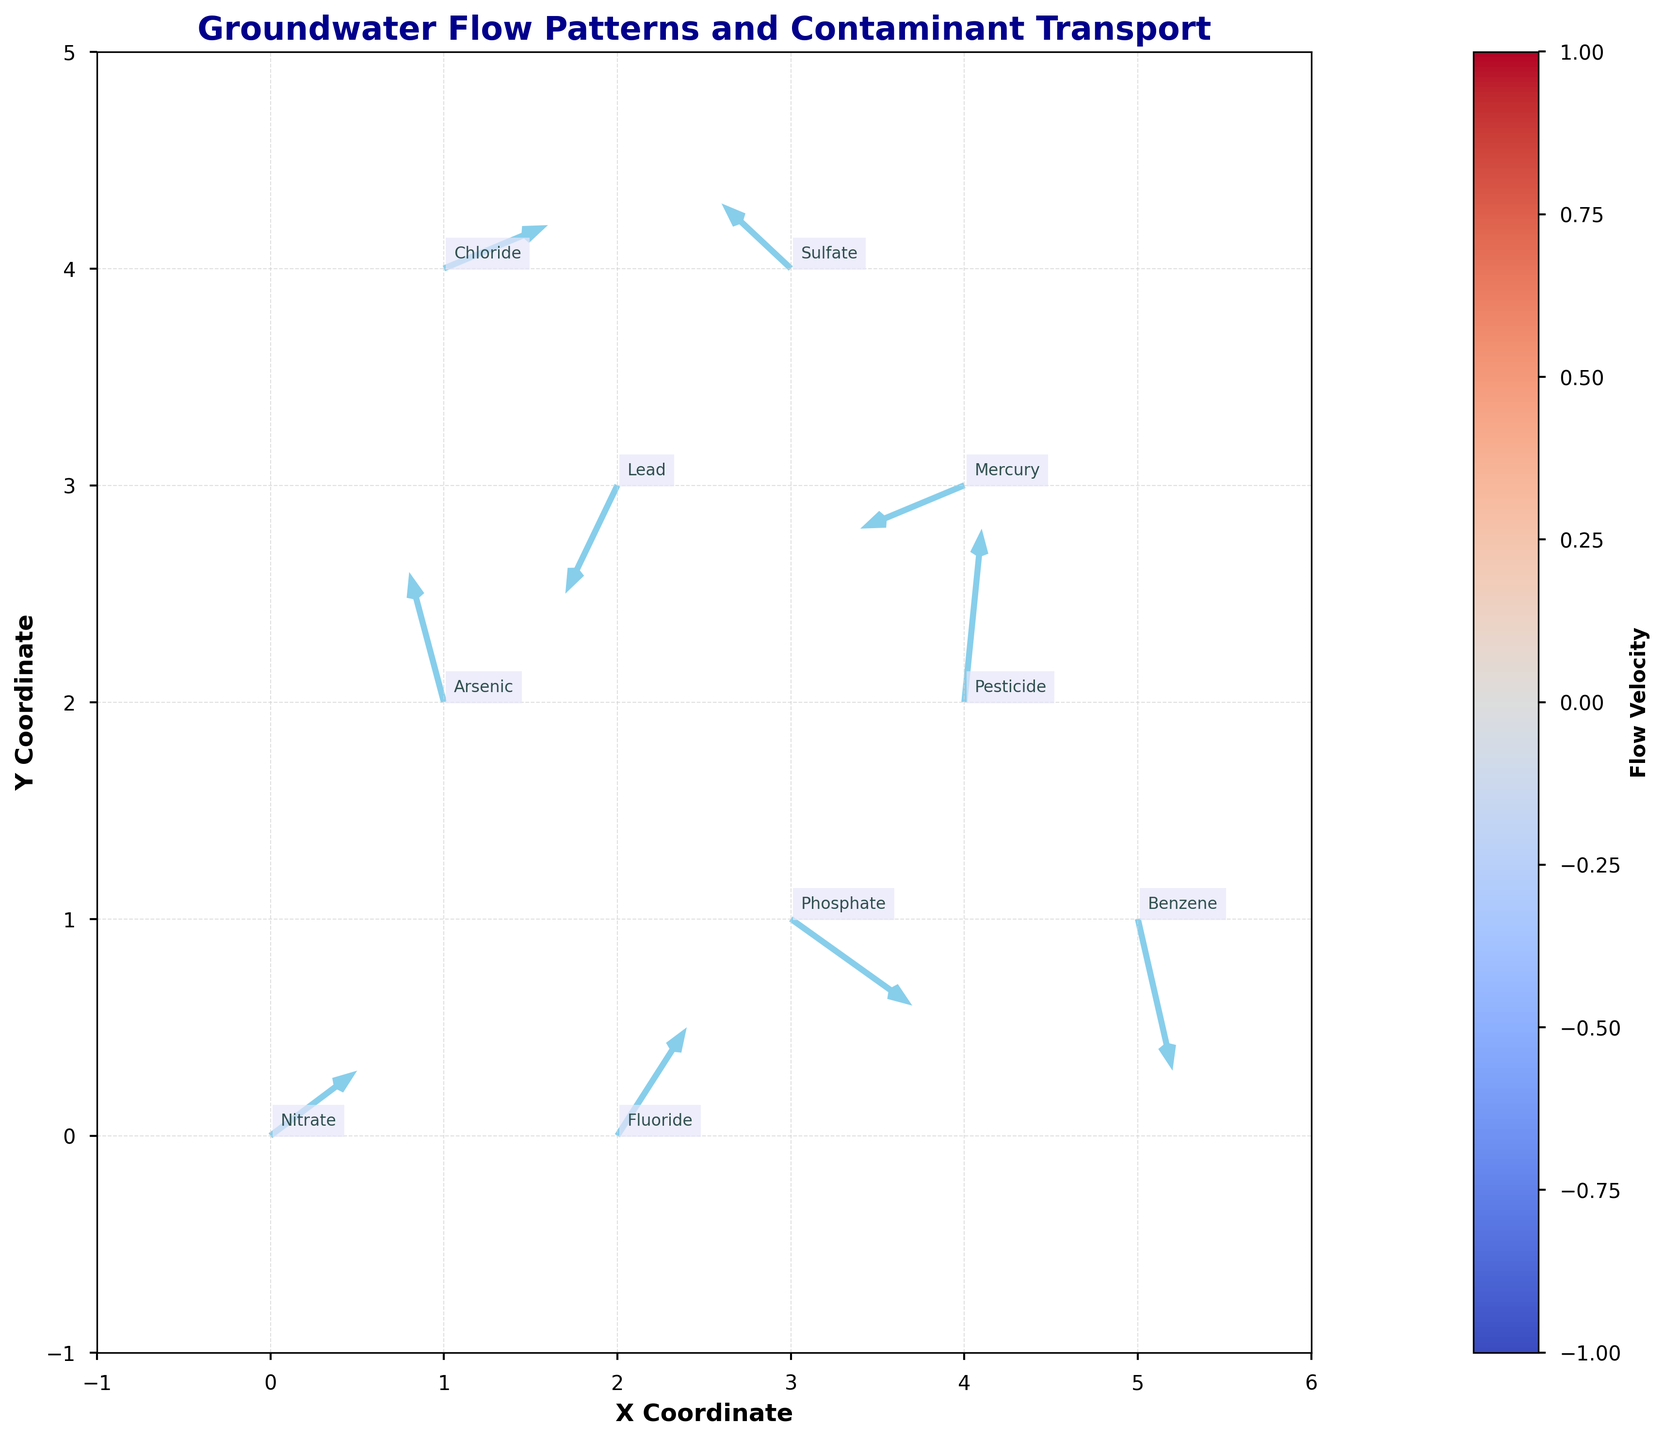Which direction does the groundwater flow at the coordinate (0,0)? Look at the arrow starting at coordinate (0,0) in the quiver plot. The arrow points slightly upward and to the right, indicating a flow in the northeast direction.
Answer: Northeast What is the title of the quiver plot? The title is written at the top of the plot. It provides an overview of what the plot represents.
Answer: Groundwater Flow Patterns and Contaminant Transport How many contaminants are represented in the plot? By counting the number of different labels annotated in the plot, we can determine the number of contaminants shown. Each contaminant label is unique.
Answer: 10 Which contaminant is located at the highest y-coordinate? Review all the contaminant labels and their positions on the plot, and identify the one with the highest y value. Chloride is placed highest in the plot.
Answer: Chloride What is the flow velocity represented by the arrow at (3,1)? The length and orientation of the arrow represent the flow velocity. For the arrow at (3,1), it points to the right and slightly downwards, with components (0.7, -0.4). The magnitude can be calculated using Pythagoras theorem.
Answer: Approximately 0.806 Compare the flow directions of Phosphate and Mercury. Which flows in the direction closer to vertical? Look at the arrows and vectors for both Phosphate (at 3,1) and Mercury (at 4,3). Mercury flows more vertically than Phosphate based on the vector components.
Answer: Mercury In which region (quadrant) do most contaminants seem to aggregate? Observe the plot and identify the region where most vectors and labels are concentrated. The upper-right quadrant (positive x and y) has the most contaminants.
Answer: Upper-right Which contaminant shows a flow direction significantly opposing the general flow trend? Compare the direction of each contaminant’s flow vector to the overall flow trend. Sulfate, at (3,4), has a vector pointing left and slightly upwards, opposing the general downward-flowing trend.
Answer: Sulfate 